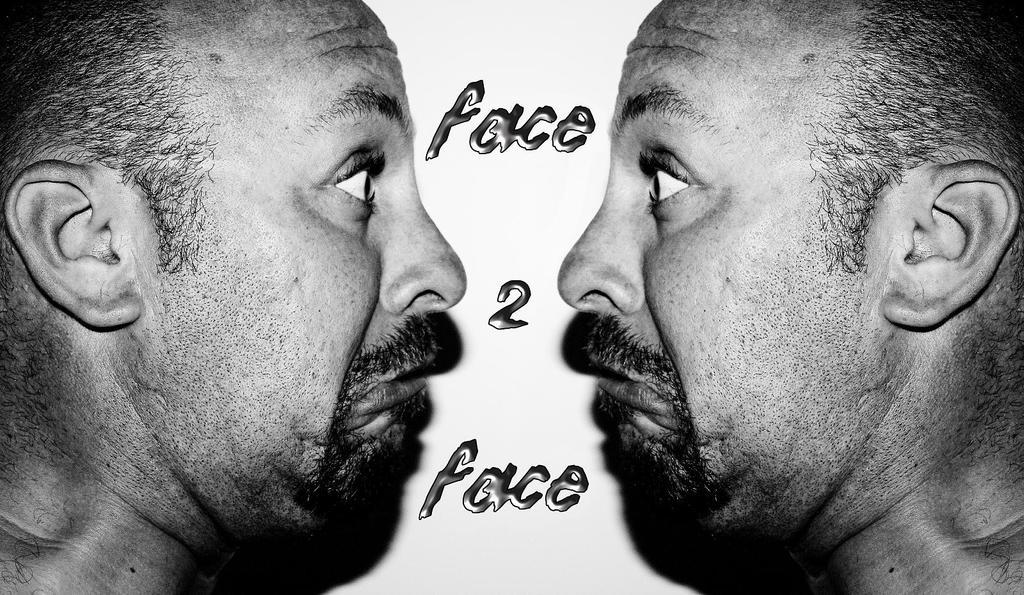How many people's faces can be seen in the image? There are two people's faces in the image. What else is present in the image besides the faces? There is text written on the image. What color scheme is used in the image? The image is in black and white. What type of cream is being used to inflate the balloon in the image? There is no cream or balloon present in the image; it only features two people's faces and text in black and white. 